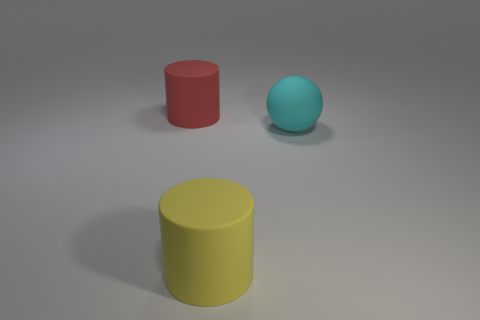Is there any other thing of the same color as the big rubber sphere?
Your answer should be compact. No. What shape is the object that is both left of the large cyan thing and behind the yellow matte object?
Your answer should be compact. Cylinder. Are there an equal number of large red cylinders that are in front of the large red thing and yellow rubber things that are in front of the cyan matte ball?
Offer a terse response. No. What number of balls are either yellow things or brown objects?
Your answer should be compact. 0. What number of yellow objects are made of the same material as the cyan sphere?
Make the answer very short. 1. There is a large thing to the left of the big yellow rubber thing; what is its shape?
Make the answer very short. Cylinder. There is a thing behind the rubber object that is to the right of the big yellow cylinder; what shape is it?
Give a very brief answer. Cylinder. Are there any other large things of the same shape as the red thing?
Your response must be concise. Yes. What is the shape of the yellow thing that is the same size as the red thing?
Give a very brief answer. Cylinder. Is there a red thing that is on the left side of the cyan ball behind the cylinder that is in front of the big red rubber cylinder?
Give a very brief answer. Yes. 